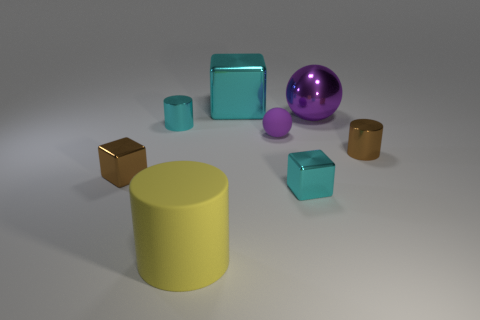What is the size of the other shiny sphere that is the same color as the small ball?
Make the answer very short. Large. What material is the small cyan object that is behind the small metallic block that is to the right of the tiny cyan metallic cylinder made of?
Offer a terse response. Metal. How many things are cyan metal balls or small cyan metallic blocks that are on the right side of the big yellow thing?
Your answer should be compact. 1. There is a purple sphere that is the same material as the big cube; what is its size?
Your answer should be compact. Large. How many purple objects are either large cylinders or tiny things?
Your answer should be very brief. 1. The metallic object that is the same color as the rubber sphere is what shape?
Offer a very short reply. Sphere. Is there any other thing that has the same material as the small brown cube?
Provide a succinct answer. Yes. Is the shape of the brown shiny object that is left of the big matte cylinder the same as the small cyan thing that is left of the rubber ball?
Provide a short and direct response. No. How many large yellow cylinders are there?
Keep it short and to the point. 1. There is a large cyan thing that is the same material as the large purple object; what shape is it?
Provide a succinct answer. Cube. 